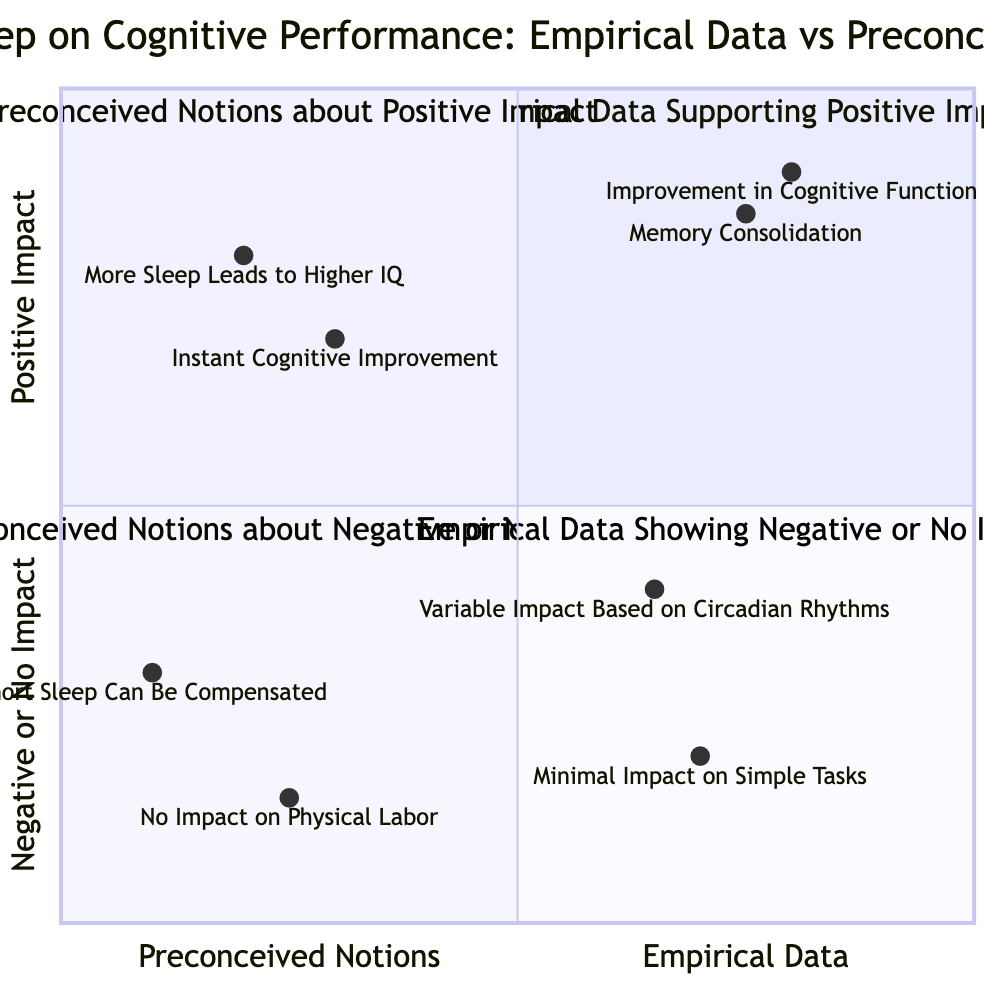What are the four quadrants in the diagram? The four quadrants in the diagram are: "Empirical Data Supporting Positive Impact," "Preconceived Notions about Positive Impact," "Preconceived Notions about Negative or No Impact," and "Empirical Data Showing Negative or No Impact."
Answer: Empirical Data Supporting Positive Impact, Preconceived Notions about Positive Impact, Preconceived Notions about Negative or No Impact, Empirical Data Showing Negative or No Impact Which example shows the greatest positive impact on cognitive performance? The example titled "Improvement in Cognitive Function" shows a 20% improvement, the highest among the examples in the diagram indicating a positive impact on cognitive performance.
Answer: Improvement in Cognitive Function What type of data does "Short Sleep Can Be Compensated" fall under? "Short Sleep Can Be Compensated" falls under Preconceived Notions about Negative or No Impact as it represents a belief rather than empirical evidence.
Answer: Preconceived Notions about Negative or No Impact Which quadrant contains examples related to studies conducted by universities? The quadrant "Empirical Data Supporting Positive Impact" contains examples related to studies conducted by universities such as Harvard Medical School and University of California, Berkeley.
Answer: Empirical Data Supporting Positive Impact How many examples are presented in the quadrant for Preconceived Notions about Positive Impact? There are two examples presented in the quadrant for Preconceived Notions about Positive Impact: "More Sleep Leads to Higher IQ" and "Instant Cognitive Improvement."
Answer: Two What percentage improvement is stated for memory consolidation? The percentage improvement stated for memory consolidation is 15%, as mentioned in the example from the University of California, Berkeley.
Answer: 15% Which quadrant shows empirical data indicating no impact from sleep deprivation? The quadrant that shows empirical data indicating no impact from sleep deprivation is "Empirical Data Showing Negative or No Impact," which contains the example "Minimal Impact on Simple Tasks."
Answer: Empirical Data Showing Negative or No Impact Which study suggests that sleep enhances memory retention? The study titled "Memory Consolidation" from the University of California, Berkeley, suggests that sleep enhances the brain's ability to form and retain new memories.
Answer: Memory Consolidation 